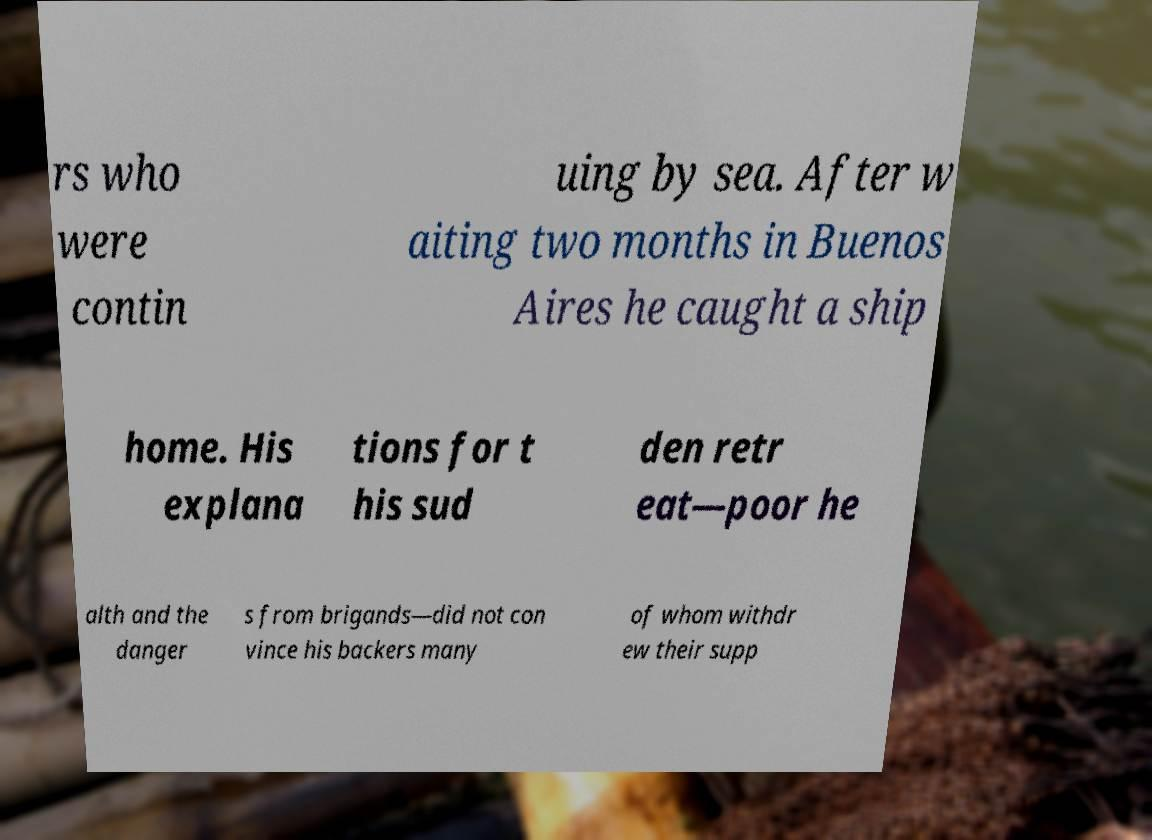Can you read and provide the text displayed in the image?This photo seems to have some interesting text. Can you extract and type it out for me? rs who were contin uing by sea. After w aiting two months in Buenos Aires he caught a ship home. His explana tions for t his sud den retr eat—poor he alth and the danger s from brigands—did not con vince his backers many of whom withdr ew their supp 